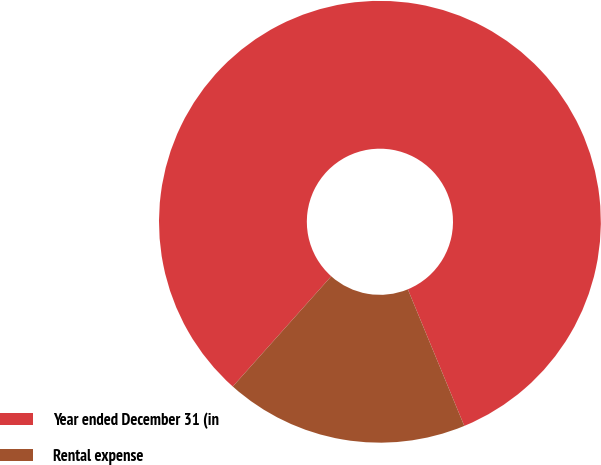Convert chart. <chart><loc_0><loc_0><loc_500><loc_500><pie_chart><fcel>Year ended December 31 (in<fcel>Rental expense<nl><fcel>82.16%<fcel>17.84%<nl></chart> 